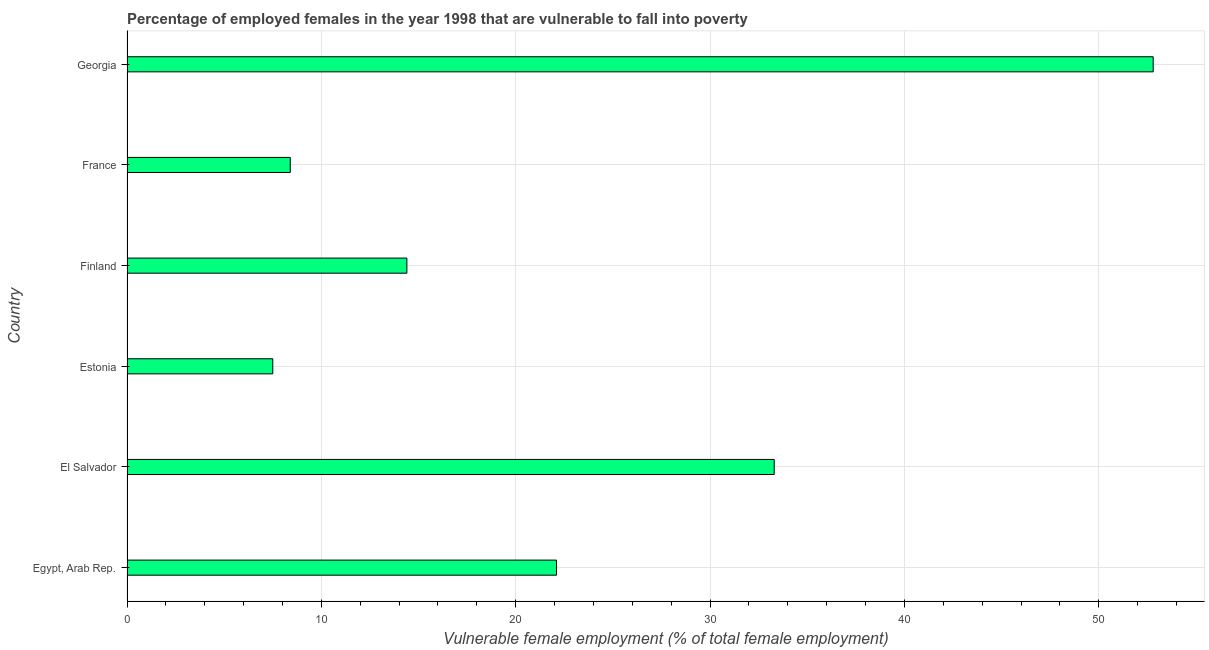What is the title of the graph?
Ensure brevity in your answer.  Percentage of employed females in the year 1998 that are vulnerable to fall into poverty. What is the label or title of the X-axis?
Offer a very short reply. Vulnerable female employment (% of total female employment). What is the percentage of employed females who are vulnerable to fall into poverty in France?
Provide a succinct answer. 8.4. Across all countries, what is the maximum percentage of employed females who are vulnerable to fall into poverty?
Provide a succinct answer. 52.8. In which country was the percentage of employed females who are vulnerable to fall into poverty maximum?
Make the answer very short. Georgia. In which country was the percentage of employed females who are vulnerable to fall into poverty minimum?
Offer a terse response. Estonia. What is the sum of the percentage of employed females who are vulnerable to fall into poverty?
Keep it short and to the point. 138.5. What is the difference between the percentage of employed females who are vulnerable to fall into poverty in Finland and Georgia?
Offer a very short reply. -38.4. What is the average percentage of employed females who are vulnerable to fall into poverty per country?
Provide a succinct answer. 23.08. What is the median percentage of employed females who are vulnerable to fall into poverty?
Provide a succinct answer. 18.25. What is the ratio of the percentage of employed females who are vulnerable to fall into poverty in Finland to that in France?
Keep it short and to the point. 1.71. What is the difference between the highest and the second highest percentage of employed females who are vulnerable to fall into poverty?
Your answer should be very brief. 19.5. Is the sum of the percentage of employed females who are vulnerable to fall into poverty in Egypt, Arab Rep. and Finland greater than the maximum percentage of employed females who are vulnerable to fall into poverty across all countries?
Your answer should be very brief. No. What is the difference between the highest and the lowest percentage of employed females who are vulnerable to fall into poverty?
Offer a very short reply. 45.3. How many bars are there?
Provide a short and direct response. 6. Are all the bars in the graph horizontal?
Provide a succinct answer. Yes. How many countries are there in the graph?
Your answer should be very brief. 6. What is the difference between two consecutive major ticks on the X-axis?
Ensure brevity in your answer.  10. What is the Vulnerable female employment (% of total female employment) in Egypt, Arab Rep.?
Your response must be concise. 22.1. What is the Vulnerable female employment (% of total female employment) of El Salvador?
Your response must be concise. 33.3. What is the Vulnerable female employment (% of total female employment) in Finland?
Offer a very short reply. 14.4. What is the Vulnerable female employment (% of total female employment) of France?
Make the answer very short. 8.4. What is the Vulnerable female employment (% of total female employment) in Georgia?
Your answer should be compact. 52.8. What is the difference between the Vulnerable female employment (% of total female employment) in Egypt, Arab Rep. and Estonia?
Give a very brief answer. 14.6. What is the difference between the Vulnerable female employment (% of total female employment) in Egypt, Arab Rep. and Finland?
Make the answer very short. 7.7. What is the difference between the Vulnerable female employment (% of total female employment) in Egypt, Arab Rep. and Georgia?
Keep it short and to the point. -30.7. What is the difference between the Vulnerable female employment (% of total female employment) in El Salvador and Estonia?
Offer a terse response. 25.8. What is the difference between the Vulnerable female employment (% of total female employment) in El Salvador and Finland?
Offer a very short reply. 18.9. What is the difference between the Vulnerable female employment (% of total female employment) in El Salvador and France?
Make the answer very short. 24.9. What is the difference between the Vulnerable female employment (% of total female employment) in El Salvador and Georgia?
Ensure brevity in your answer.  -19.5. What is the difference between the Vulnerable female employment (% of total female employment) in Estonia and Finland?
Ensure brevity in your answer.  -6.9. What is the difference between the Vulnerable female employment (% of total female employment) in Estonia and France?
Ensure brevity in your answer.  -0.9. What is the difference between the Vulnerable female employment (% of total female employment) in Estonia and Georgia?
Offer a terse response. -45.3. What is the difference between the Vulnerable female employment (% of total female employment) in Finland and France?
Make the answer very short. 6. What is the difference between the Vulnerable female employment (% of total female employment) in Finland and Georgia?
Keep it short and to the point. -38.4. What is the difference between the Vulnerable female employment (% of total female employment) in France and Georgia?
Make the answer very short. -44.4. What is the ratio of the Vulnerable female employment (% of total female employment) in Egypt, Arab Rep. to that in El Salvador?
Your answer should be very brief. 0.66. What is the ratio of the Vulnerable female employment (% of total female employment) in Egypt, Arab Rep. to that in Estonia?
Offer a very short reply. 2.95. What is the ratio of the Vulnerable female employment (% of total female employment) in Egypt, Arab Rep. to that in Finland?
Your response must be concise. 1.53. What is the ratio of the Vulnerable female employment (% of total female employment) in Egypt, Arab Rep. to that in France?
Your answer should be very brief. 2.63. What is the ratio of the Vulnerable female employment (% of total female employment) in Egypt, Arab Rep. to that in Georgia?
Provide a short and direct response. 0.42. What is the ratio of the Vulnerable female employment (% of total female employment) in El Salvador to that in Estonia?
Give a very brief answer. 4.44. What is the ratio of the Vulnerable female employment (% of total female employment) in El Salvador to that in Finland?
Ensure brevity in your answer.  2.31. What is the ratio of the Vulnerable female employment (% of total female employment) in El Salvador to that in France?
Give a very brief answer. 3.96. What is the ratio of the Vulnerable female employment (% of total female employment) in El Salvador to that in Georgia?
Keep it short and to the point. 0.63. What is the ratio of the Vulnerable female employment (% of total female employment) in Estonia to that in Finland?
Keep it short and to the point. 0.52. What is the ratio of the Vulnerable female employment (% of total female employment) in Estonia to that in France?
Your response must be concise. 0.89. What is the ratio of the Vulnerable female employment (% of total female employment) in Estonia to that in Georgia?
Provide a short and direct response. 0.14. What is the ratio of the Vulnerable female employment (% of total female employment) in Finland to that in France?
Your response must be concise. 1.71. What is the ratio of the Vulnerable female employment (% of total female employment) in Finland to that in Georgia?
Offer a very short reply. 0.27. What is the ratio of the Vulnerable female employment (% of total female employment) in France to that in Georgia?
Provide a short and direct response. 0.16. 